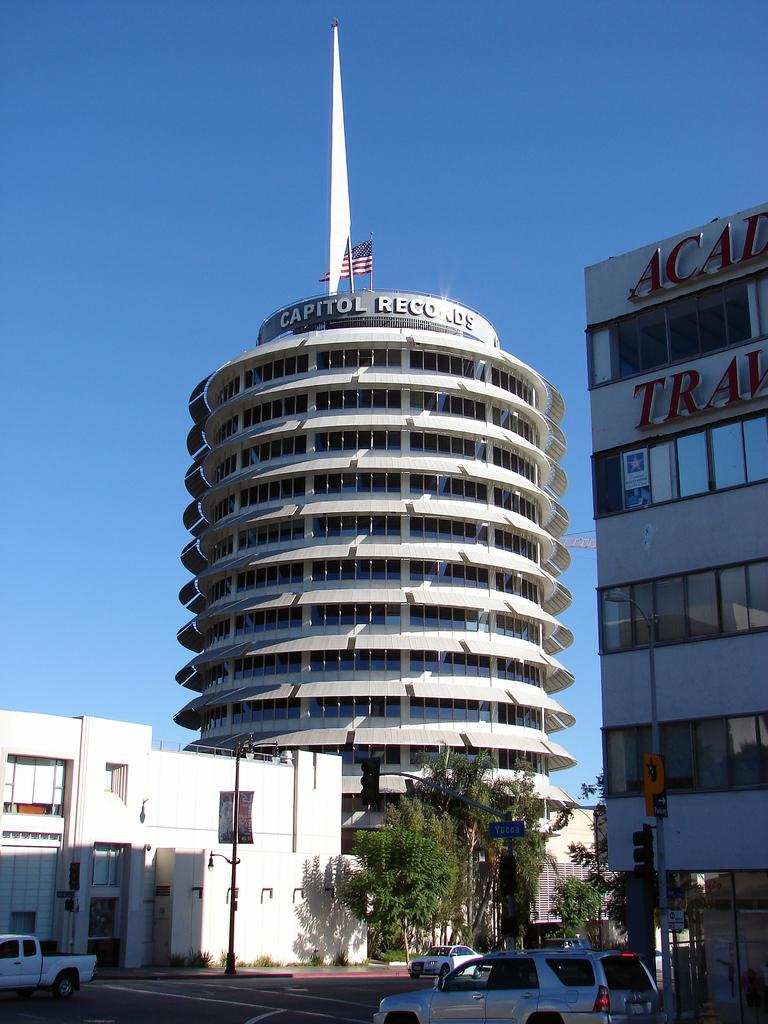What type of structures can be seen in the image? There are buildings in the image. What other natural elements are present in the image? There are trees in the image. Are there any man-made objects visible besides the buildings? Yes, there are vehicles in the image. What can be seen in the sky in the image? The sky is visible in the image. What type of whip is being used by the stranger in the image? There is no stranger or whip present in the image. What type of bears can be seen in the image? There are no bears present in the image. 